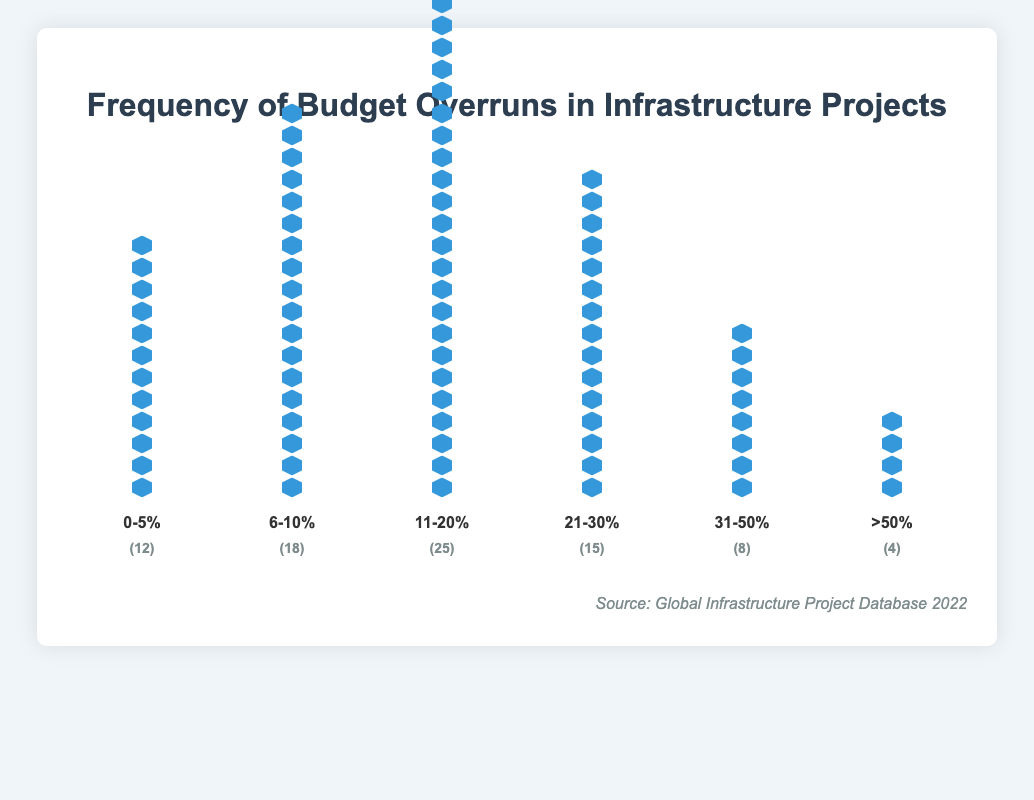How many projects experienced budget overruns in the range of 0-5%? The figure has a column labeled "0-5%" and it shows 12 building icons.
Answer: 12 What's the total number of projects with budget overruns more than 50%? The column labeled ">50%" shows 4 building icons.
Answer: 4 Which budget overrun range has the highest number of projects? The column labeled "11-20%" has the most building icons, totaling 25.
Answer: 11-20% How many projects have budget overruns between 6% and 30% inclusive? Add the counts from the "6-10%", "11-20%", and "21-30%" columns. (18 + 25 + 15 = 58)
Answer: 58 What is the combined percentage of projects with budget overruns below 11%? (12 + 18 = 30), then calculate (30 / 82) * 100 = 36.59%
Answer: 36.59% How does the count of projects in the 31-50% range compare to the number of projects in the 0-5% range? The count for "31-50%" is 8, and for "0-5%" it is 12. Compare 8 and 12.
Answer: The 31-50% range has 4 fewer projects What's the average number of projects across the six budget overrun ranges? Add the counts (12 + 18 + 25 + 15 + 8 + 4 = 82) and divide by 6. (82 / 6 ≈ 13.67)
Answer: 13.67 Which two budget overrun ranges combined make up the majority of the total projects? Find two ranges with combined counts over 41 (half of 82). (11-20%) and (6-10%) combined have (25 + 18 = 43).
Answer: 6-10% and 11-20% If you combined the projects with budget overruns over 30%, what fraction of the total projects would that be? Add the counts from "31-50%" and ">50%" (8 + 4 = 12). Then, calculate 12 / 82.
Answer: 12/82 How many more projects are in the 11-20% range compared to the 21-30% range? Subtract the count of the "21-30%" range from the "11-20%" range (25 - 15 = 10).
Answer: 10 